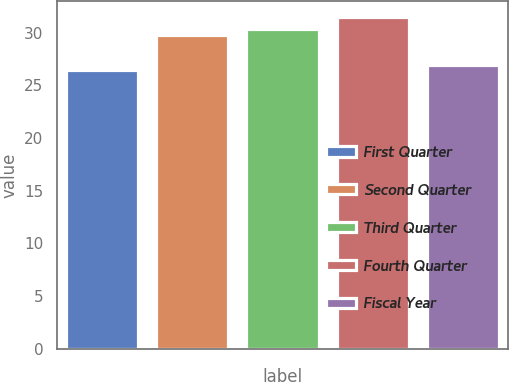Convert chart to OTSL. <chart><loc_0><loc_0><loc_500><loc_500><bar_chart><fcel>First Quarter<fcel>Second Quarter<fcel>Third Quarter<fcel>Fourth Quarter<fcel>Fiscal Year<nl><fcel>26.46<fcel>29.82<fcel>30.32<fcel>31.44<fcel>26.96<nl></chart> 